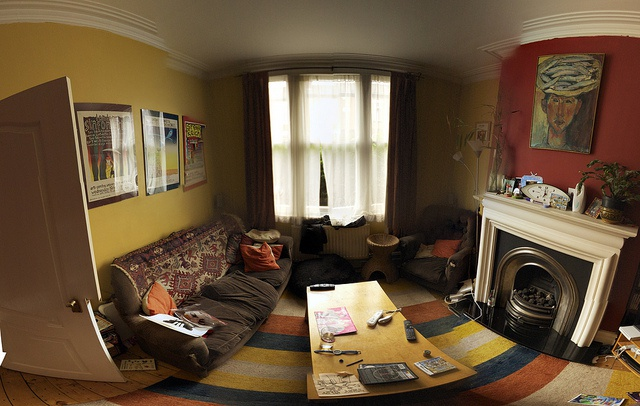Describe the objects in this image and their specific colors. I can see couch in gray, black, and maroon tones, potted plant in gray, black, maroon, and olive tones, book in gray and tan tones, book in gray and black tones, and book in gray, lightgray, lightpink, pink, and black tones in this image. 